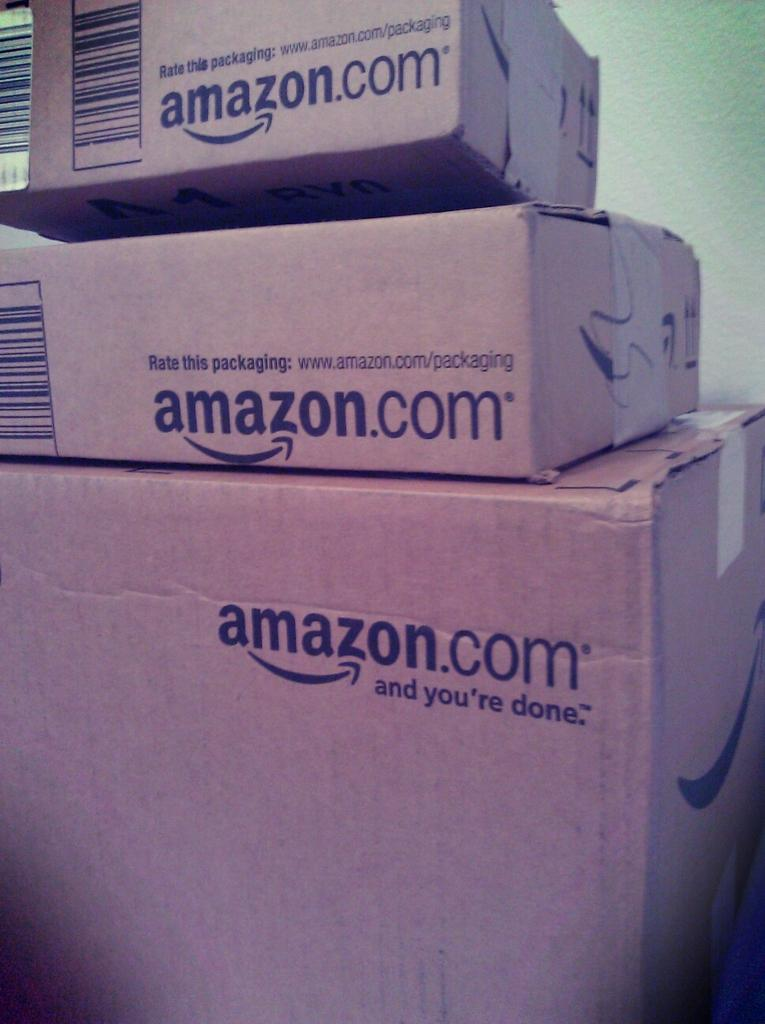Provide a one-sentence caption for the provided image. A stack of boxes bearing the name "amazon.com" on them. 